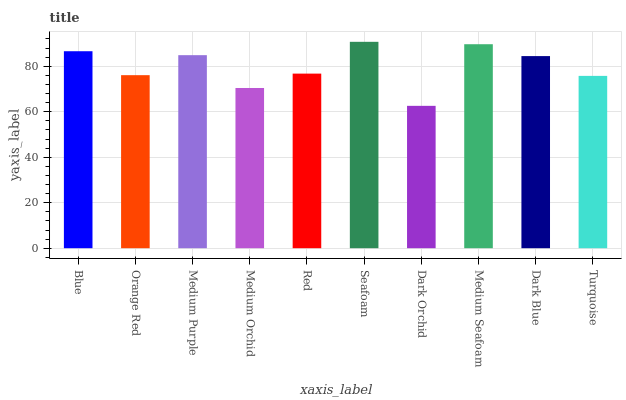Is Dark Orchid the minimum?
Answer yes or no. Yes. Is Seafoam the maximum?
Answer yes or no. Yes. Is Orange Red the minimum?
Answer yes or no. No. Is Orange Red the maximum?
Answer yes or no. No. Is Blue greater than Orange Red?
Answer yes or no. Yes. Is Orange Red less than Blue?
Answer yes or no. Yes. Is Orange Red greater than Blue?
Answer yes or no. No. Is Blue less than Orange Red?
Answer yes or no. No. Is Dark Blue the high median?
Answer yes or no. Yes. Is Red the low median?
Answer yes or no. Yes. Is Medium Seafoam the high median?
Answer yes or no. No. Is Turquoise the low median?
Answer yes or no. No. 